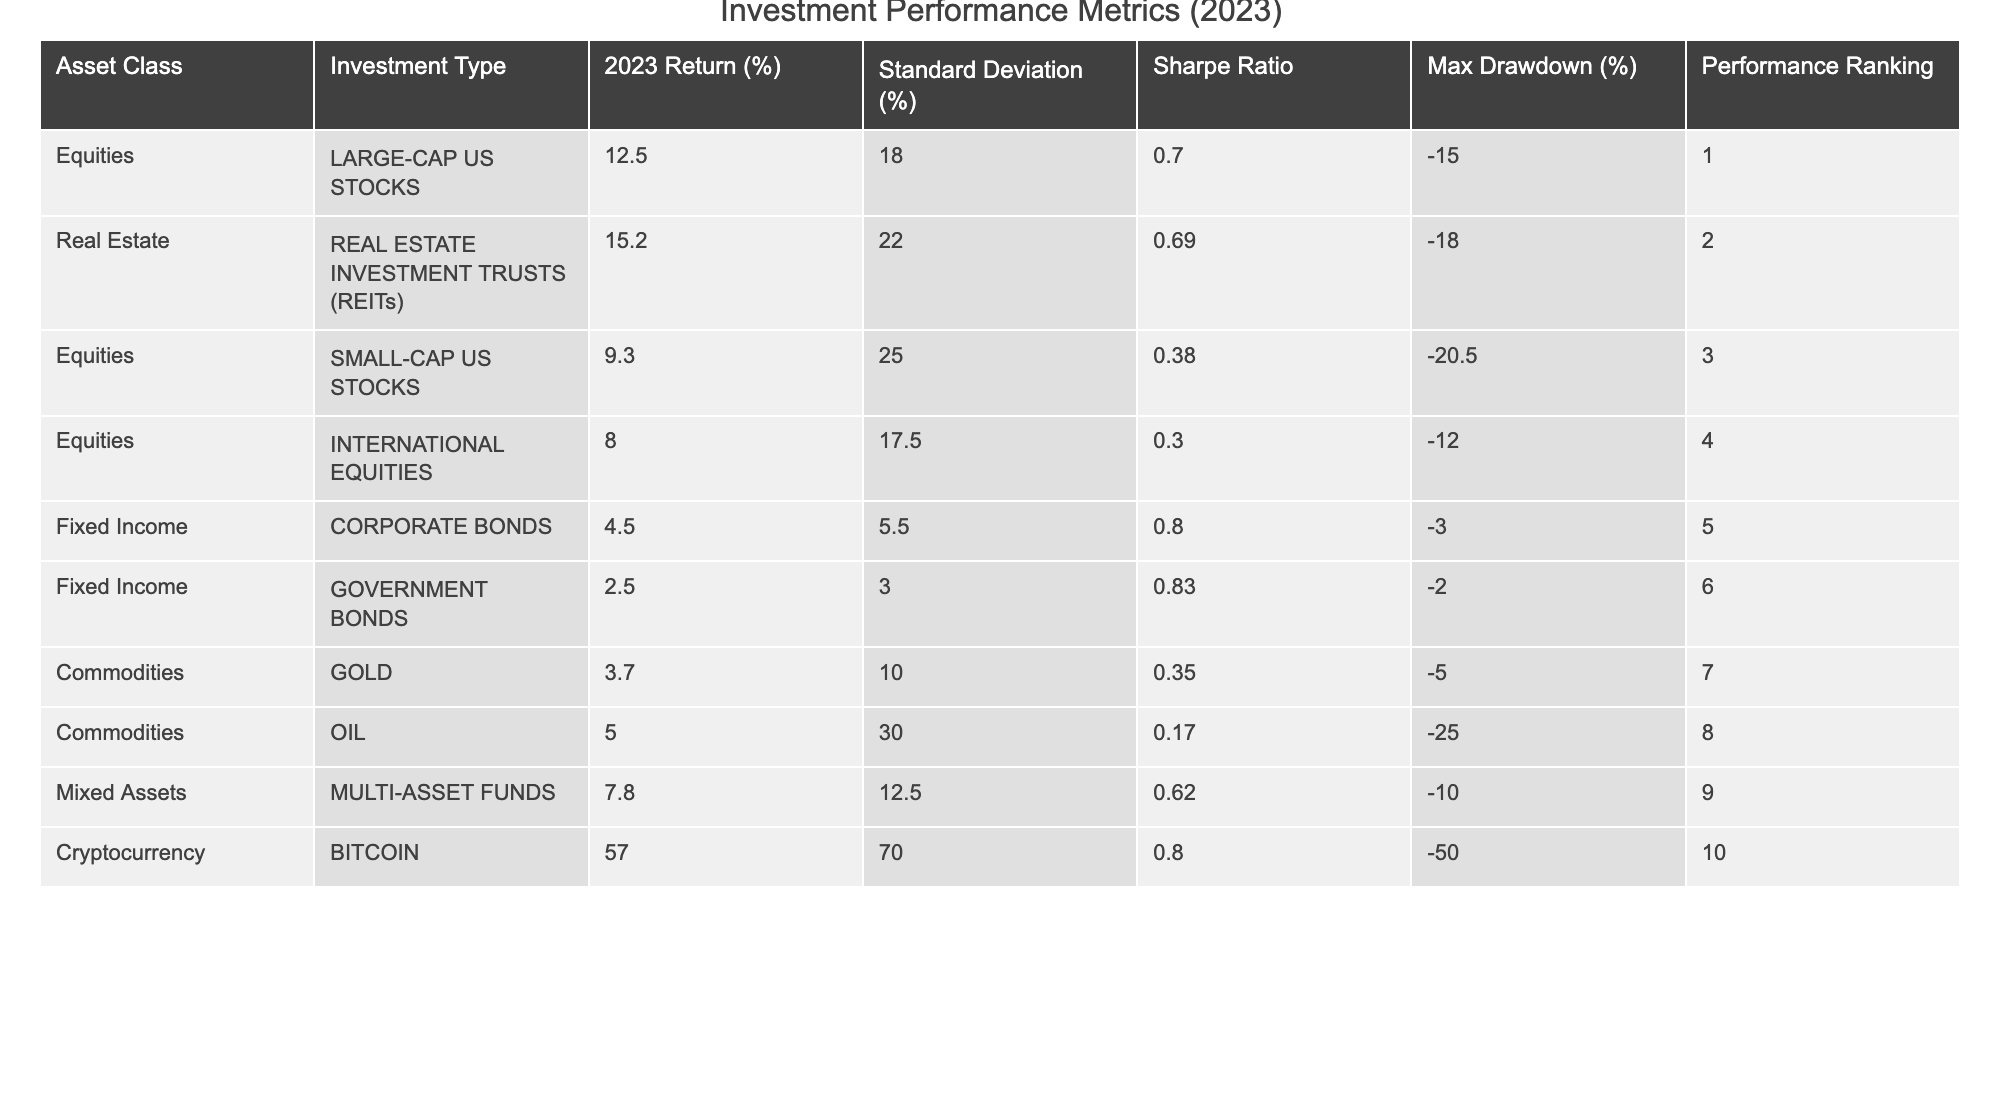What is the highest return percentage among the asset classes? In the table, the asset class with the highest return percentage in 2023 is Bitcoin at 57.0%.
Answer: 57.0% Which investment type has the highest Sharpe Ratio? The investment type with the highest Sharpe Ratio is Government Bonds, with a ratio of 0.83.
Answer: Government Bonds What is the performance ranking of International Equities? The performance ranking of International Equities is 4 as indicated in the table.
Answer: 4 What is the average return of Fixed Income asset classes? The returns for Corporate Bonds and Government Bonds are 4.5% and 2.5%, respectively. The average return is (4.5 + 2.5) / 2 = 3.5%.
Answer: 3.5% Is the maximum drawdown for Gold less than that for Small-Cap US Stocks? Gold has a maximum drawdown of -5.0%, while Small-Cap US Stocks have a maximum drawdown of -20.5%. Since -5.0% is greater than -20.5%, the statement is true.
Answer: Yes Which asset class has the lowest performance ranking and what is its return? The asset class with the lowest performance ranking is Oil, ranked 8th, with a return of 5.0%.
Answer: Oil, 5.0% What is the difference in return between Large-Cap US Stocks and Small-Cap US Stocks? Large-Cap US Stocks have a return of 12.5%, and Small-Cap US Stocks have a return of 9.3%. The difference is 12.5% - 9.3% = 3.2%.
Answer: 3.2% What is the standard deviation of Real Estate Investment Trusts? The standard deviation for Real Estate Investment Trusts (REITs) is 22.0% as shown in the table.
Answer: 22.0% How does the Sharpe Ratio of Corporate Bonds compare to that of Oil? The Sharpe Ratio for Corporate Bonds is 0.80, while for Oil it is 0.17. Since 0.80 is greater than 0.17, Corporate Bonds have a better ratio.
Answer: Better What is the total maximum drawdown from all asset classes? The maximum drawdown values are -15.0, -20.5, -12.0, -3.0, -2.0, -18.0, -5.0, -25.0, -10.0, and -50.0. The sum is -15.0 - 20.5 - 12.0 - 3.0 - 2.0 - 18.0 - 5.0 - 25.0 - 10.0 - 50.0 = -151.5%.
Answer: -151.5% 